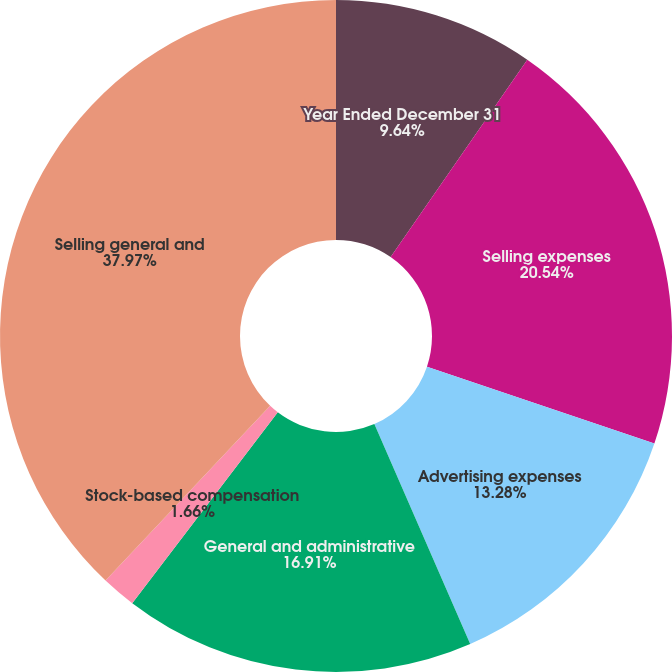<chart> <loc_0><loc_0><loc_500><loc_500><pie_chart><fcel>Year Ended December 31<fcel>Selling expenses<fcel>Advertising expenses<fcel>General and administrative<fcel>Stock-based compensation<fcel>Selling general and<nl><fcel>9.64%<fcel>20.54%<fcel>13.28%<fcel>16.91%<fcel>1.66%<fcel>37.97%<nl></chart> 